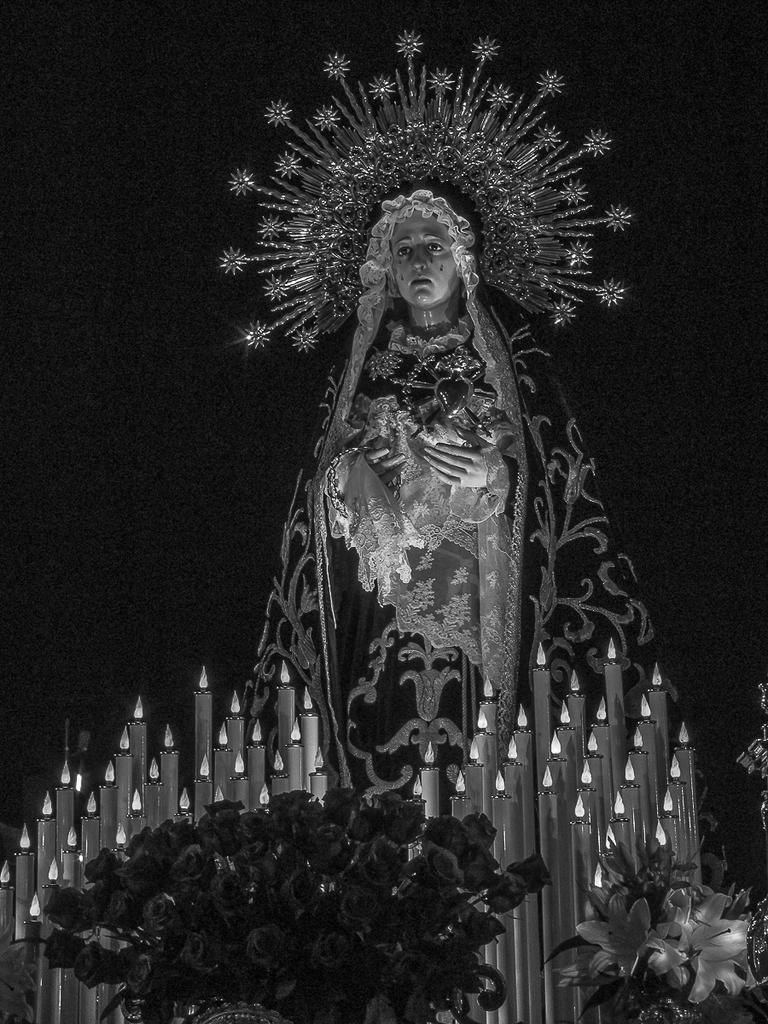What is the color scheme of the image? The image is black and white. What is the main subject in the image? There is a statue in the image. What can be seen on the statue's head? The statue has a crown and a veil. What other objects are present in the image? There are candles and flower bouquets in the image. How would you describe the background of the image? The background of the image is dark. Is there a cobweb visible on the statue in the image? There is no mention of a cobweb in the provided facts, so we cannot determine if one is present in the image. What type of record is being played in the background of the image? There is no mention of a record or any sound in the provided facts, so we cannot determine if one is present in the image. 